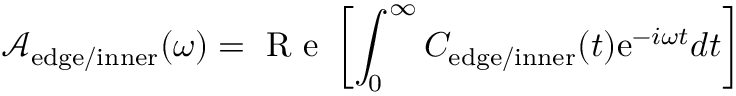<formula> <loc_0><loc_0><loc_500><loc_500>\mathcal { A } _ { e d g e / i n n e r } ( \omega ) = R e \left [ \int _ { 0 } ^ { \infty } C _ { e d g e / i n n e r } ( t ) e ^ { - i \omega t } d t \right ]</formula> 